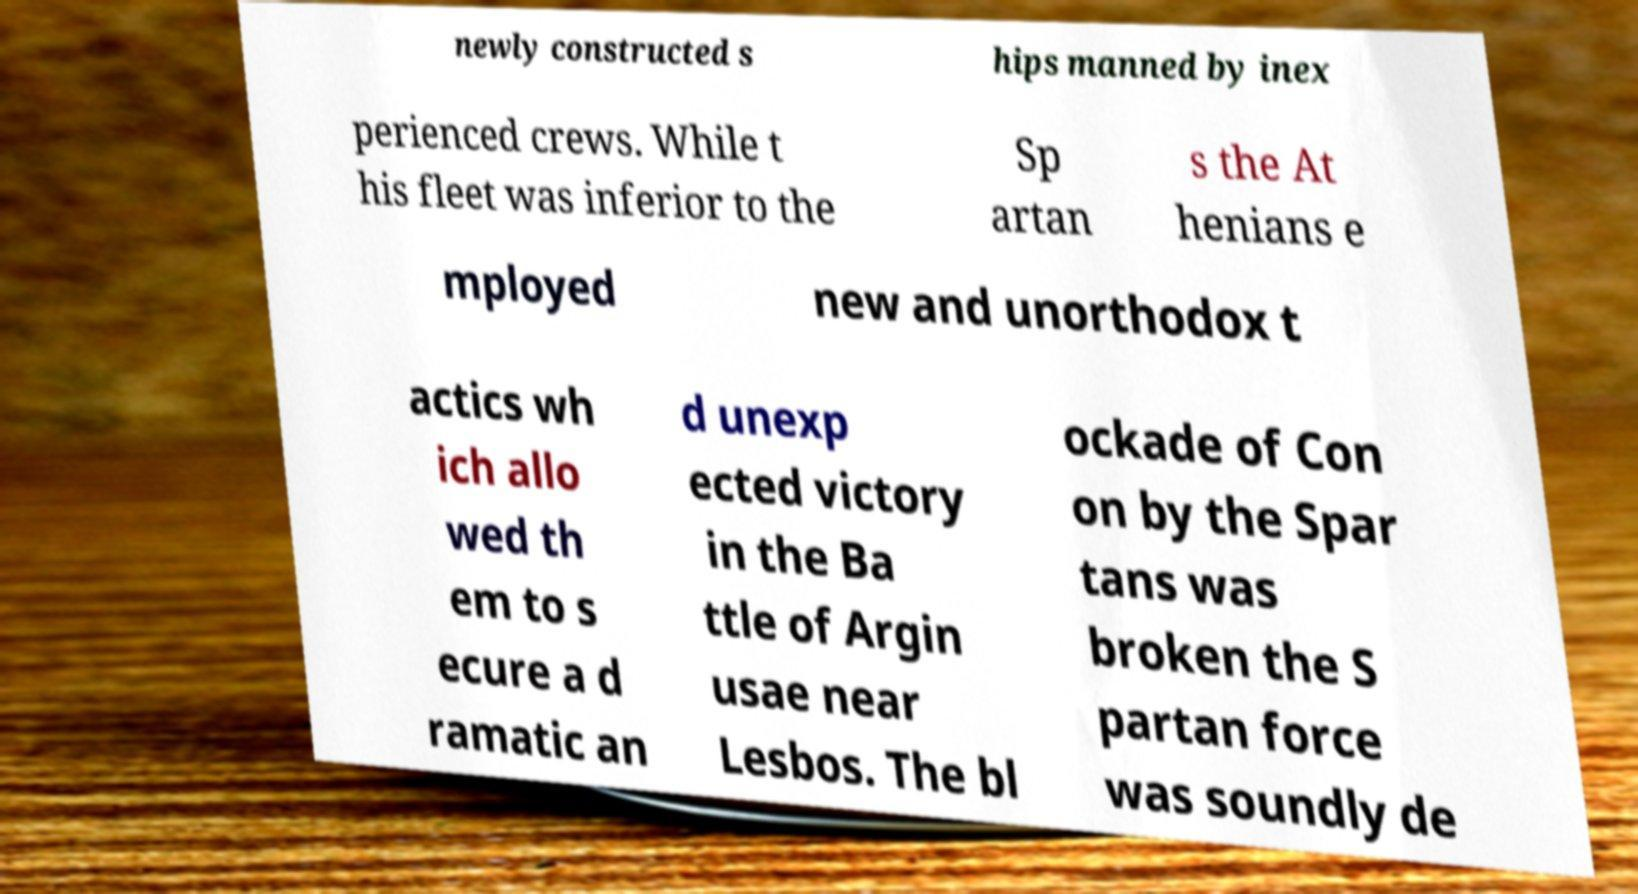Please identify and transcribe the text found in this image. newly constructed s hips manned by inex perienced crews. While t his fleet was inferior to the Sp artan s the At henians e mployed new and unorthodox t actics wh ich allo wed th em to s ecure a d ramatic an d unexp ected victory in the Ba ttle of Argin usae near Lesbos. The bl ockade of Con on by the Spar tans was broken the S partan force was soundly de 